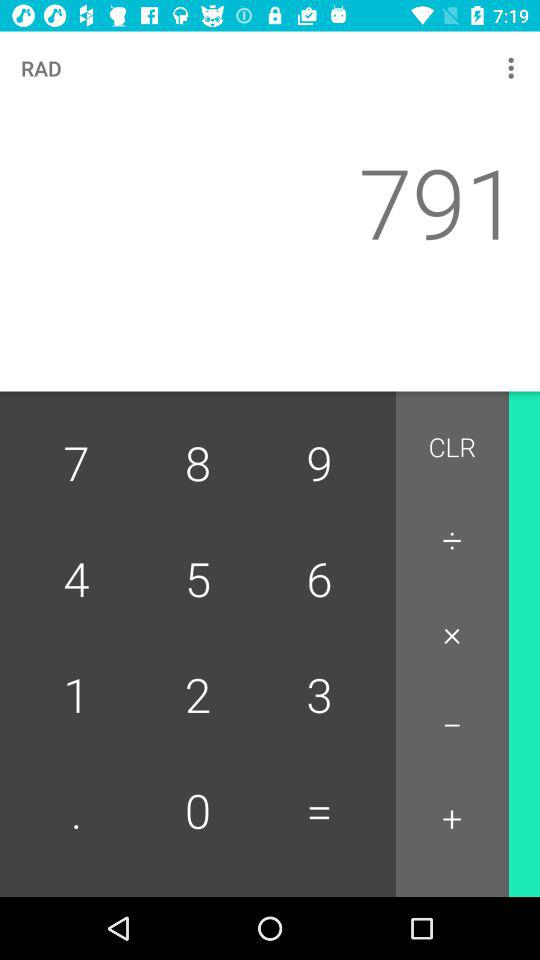What is the full form of RAD?
When the provided information is insufficient, respond with <no answer>. <no answer> 